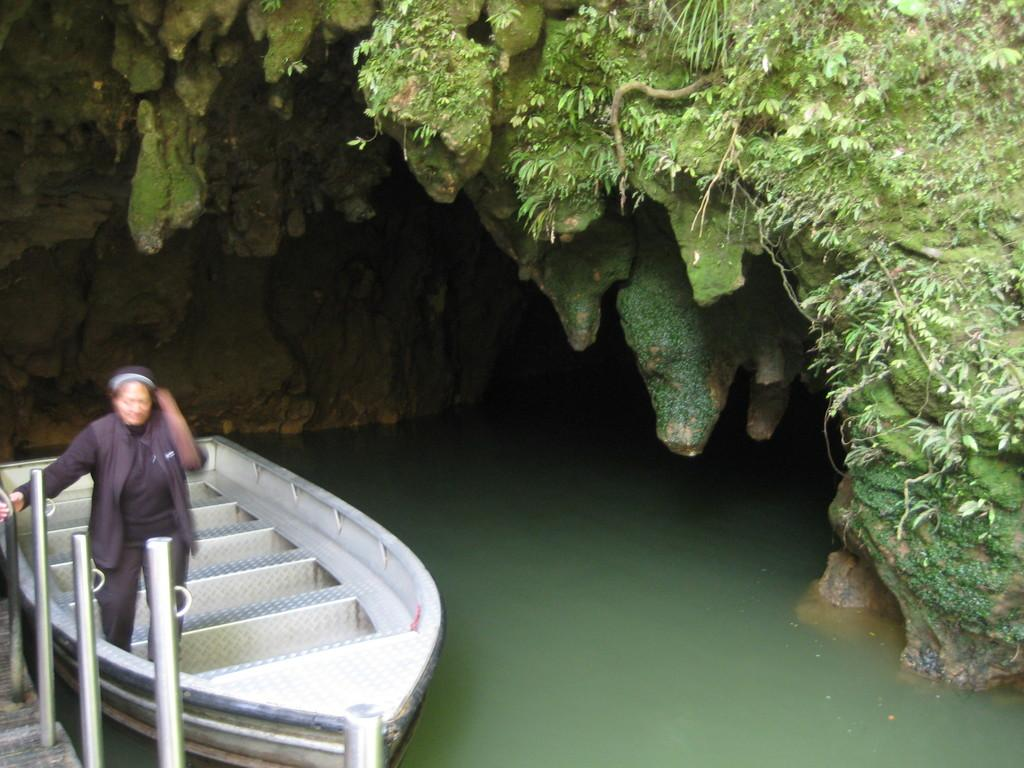What is the primary element in the image? There is water in the image. What is floating on the water? There is a boat on the water. Who is on the boat? There is a woman on the boat. What is located near the water? There is a cave in the image. What is growing on the cave? There are plants on the cave. What material is used for the rods in the image? There are metal rods in the image. What type of plastic is used to make the sponge in the image? There is no sponge present in the image, so it is not possible to determine the type of plastic used. 